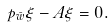<formula> <loc_0><loc_0><loc_500><loc_500>\ p _ { \bar { w } } \xi - A \xi = 0 .</formula> 